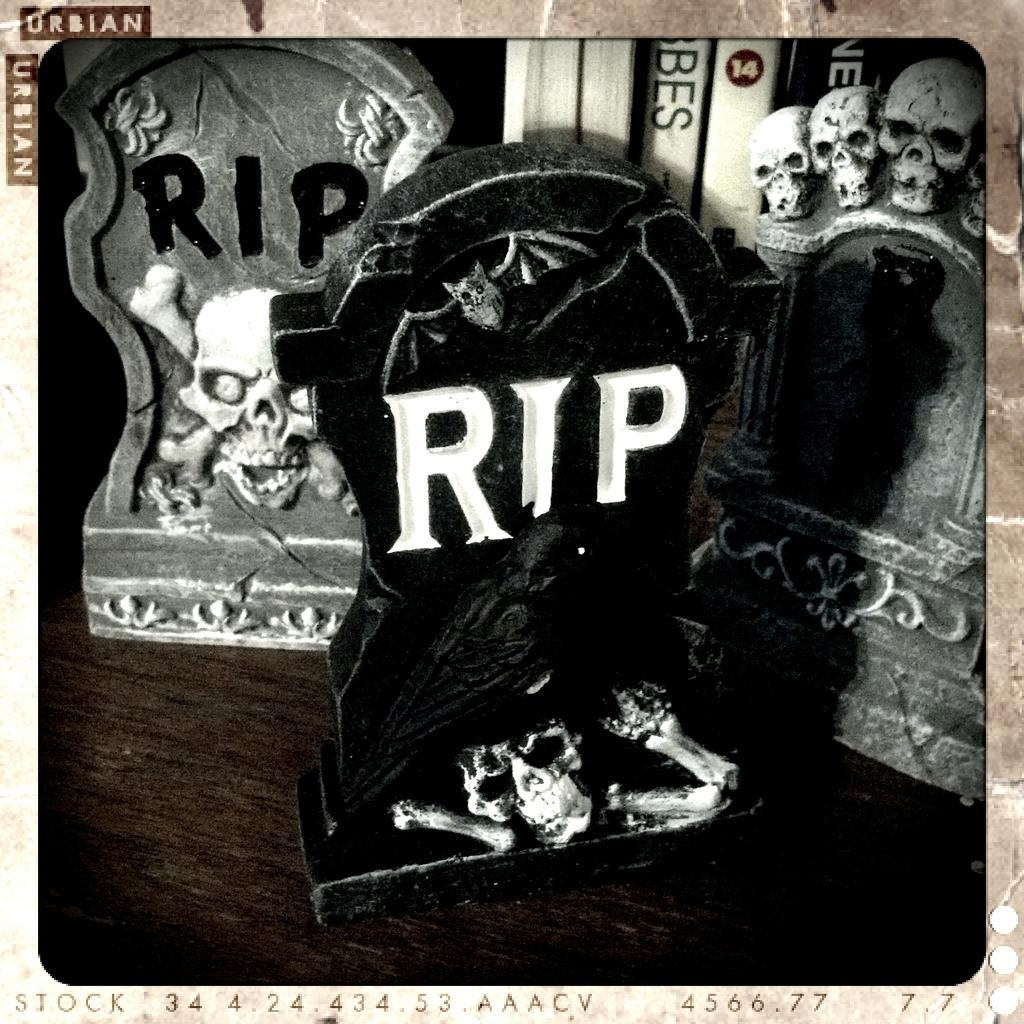<image>
Provide a brief description of the given image. The small RIP headstones were on the table on display. 